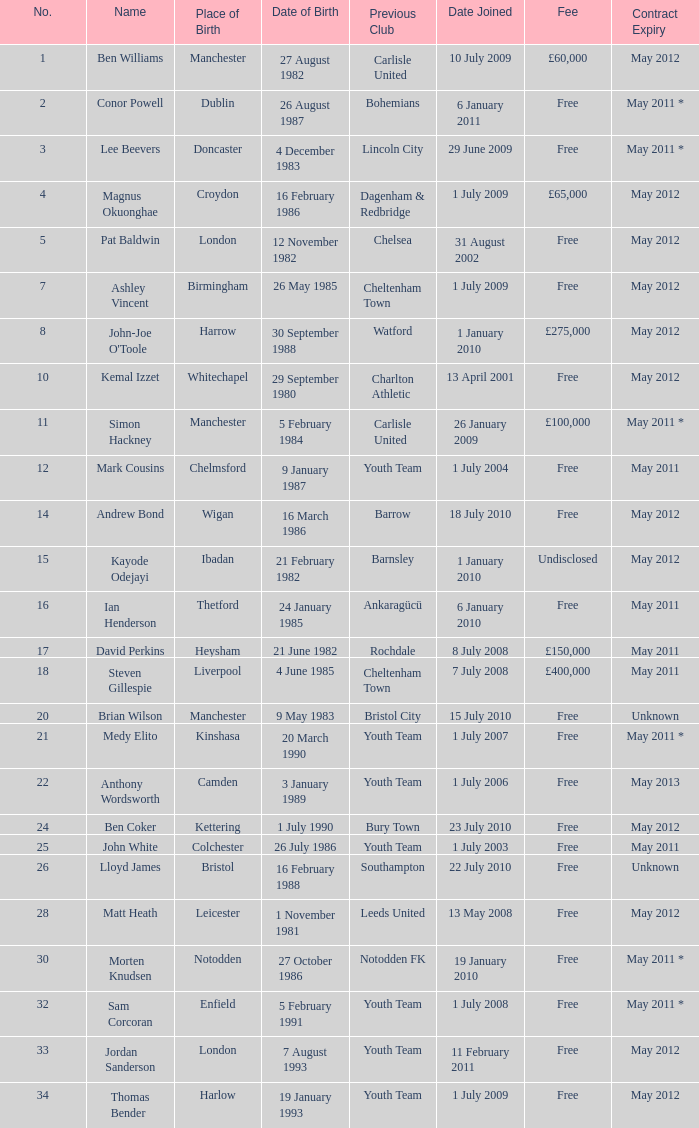For the ben williams name, what was the prior club? Carlisle United. 